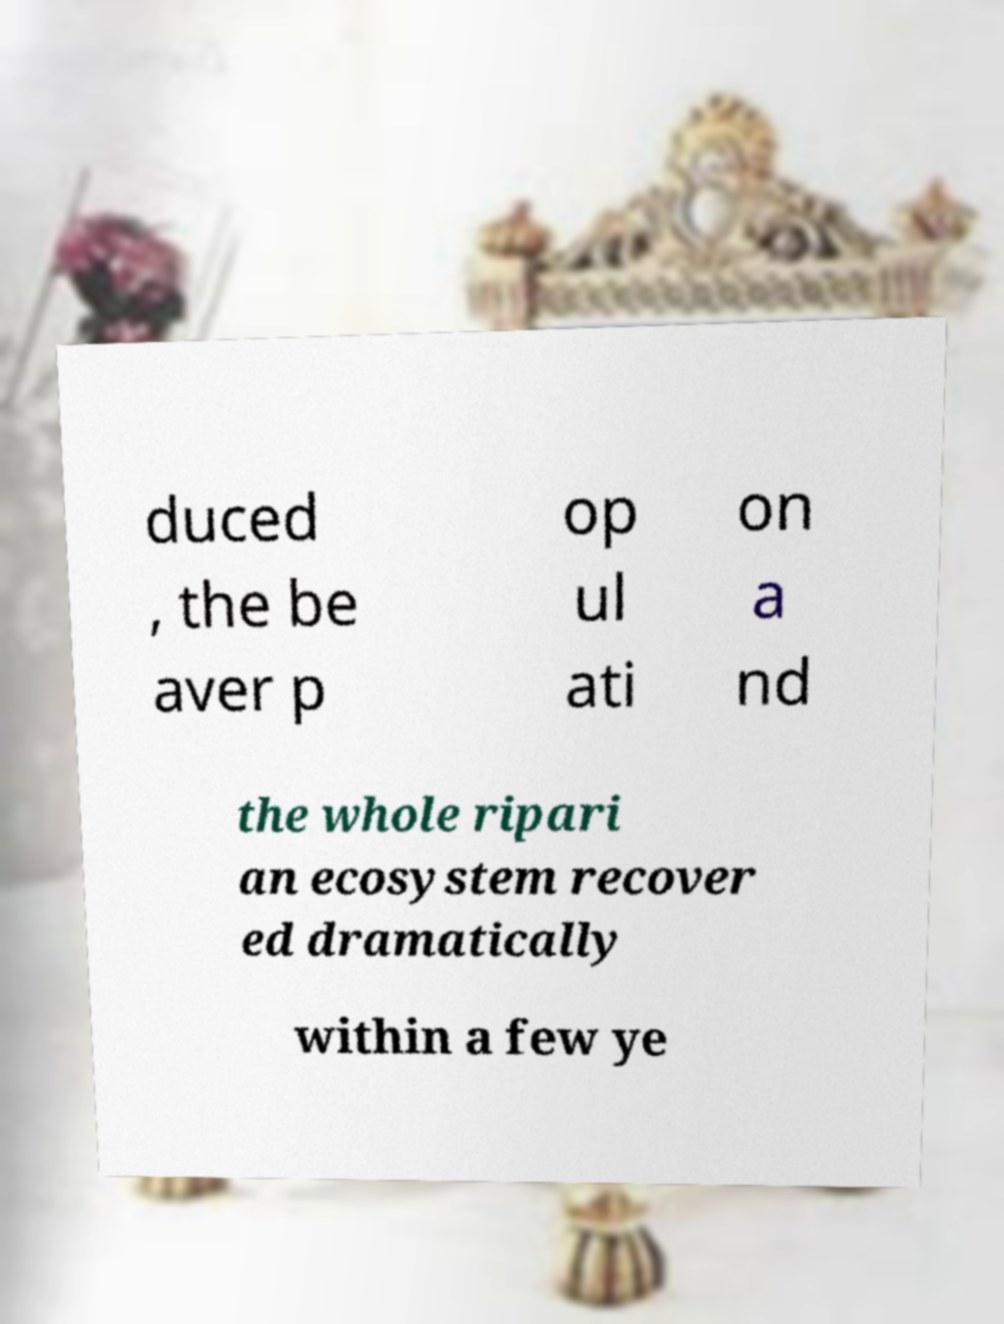Could you extract and type out the text from this image? duced , the be aver p op ul ati on a nd the whole ripari an ecosystem recover ed dramatically within a few ye 